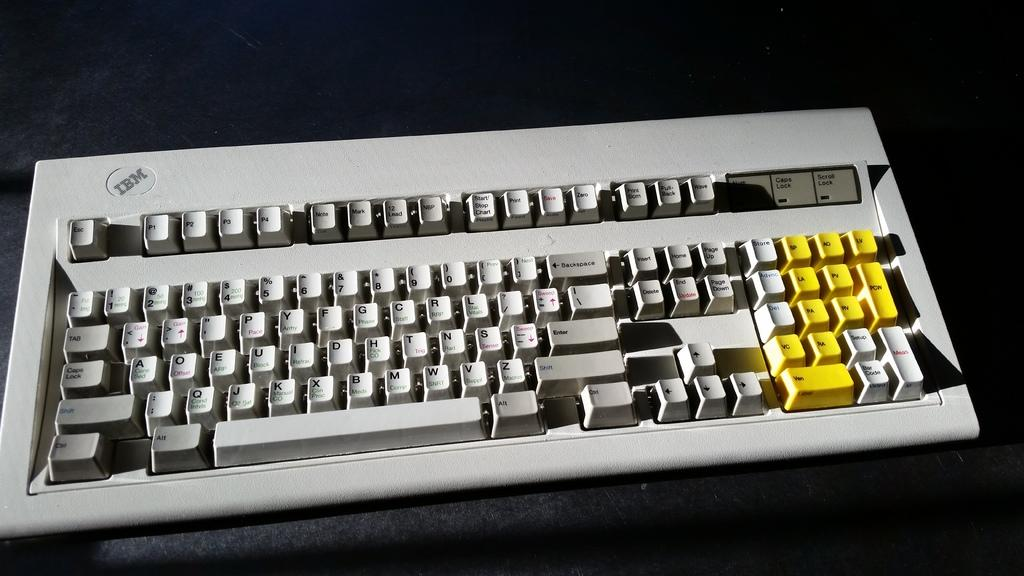<image>
Relay a brief, clear account of the picture shown. White keyboard from IBM that includes yellow keys 